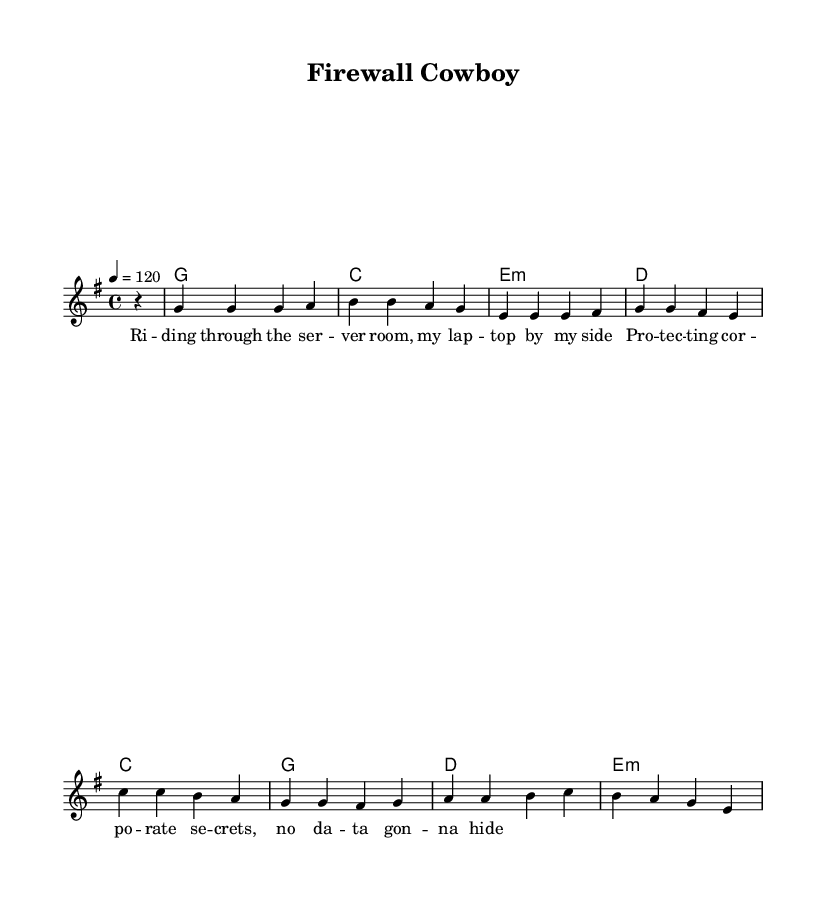What is the key signature of this music? The key signature is G major, which has one sharp (F#).
Answer: G major What is the time signature of this piece? The time signature is 4/4, which means there are four beats in a measure.
Answer: 4/4 What is the tempo marking for this piece? The tempo marking indicates a speed of 120 beats per minute (BPM).
Answer: 120 How many measures are in the verse? The verse contains four measures as indicated by the partial and full measure counts in the melody.
Answer: Four What is the primary theme of the lyrics? The primary theme revolves around protecting corporate secrets and data security, linking it to the imagery of a 'firewall cowboy.'
Answer: Corporate espionage What chord follows the 'C' chord in the progression? The chord that follows the 'C' chord in the progression is 'E minor.'
Answer: E minor What kind of lyrics are present in this music? The lyrics reflect a narrative style, telling a story about digital security and protection against hackers.
Answer: Narrative 